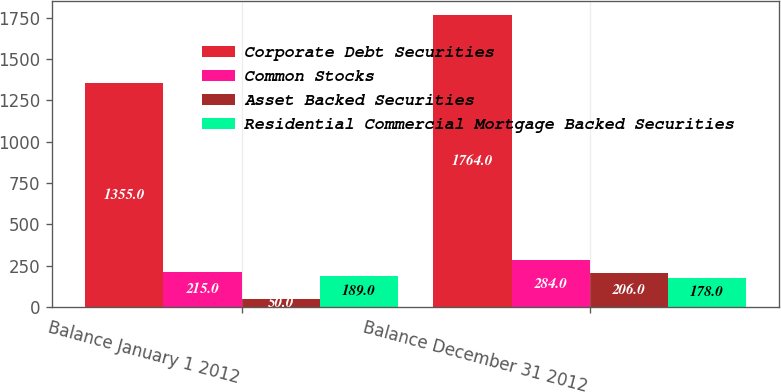Convert chart to OTSL. <chart><loc_0><loc_0><loc_500><loc_500><stacked_bar_chart><ecel><fcel>Balance January 1 2012<fcel>Balance December 31 2012<nl><fcel>Corporate Debt Securities<fcel>1355<fcel>1764<nl><fcel>Common Stocks<fcel>215<fcel>284<nl><fcel>Asset Backed Securities<fcel>50<fcel>206<nl><fcel>Residential Commercial Mortgage Backed Securities<fcel>189<fcel>178<nl></chart> 